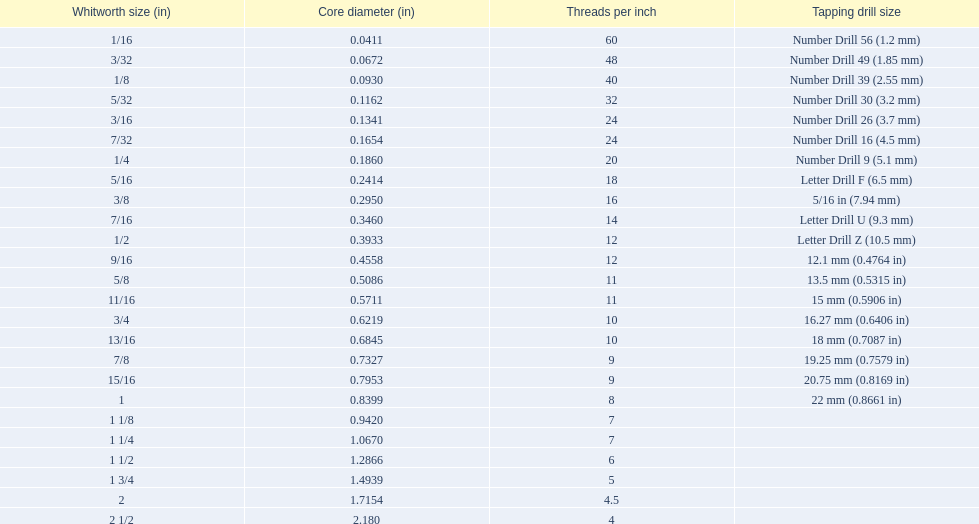What are all of the whitworth sizes in the british standard whitworth? 1/16, 3/32, 1/8, 5/32, 3/16, 7/32, 1/4, 5/16, 3/8, 7/16, 1/2, 9/16, 5/8, 11/16, 3/4, 13/16, 7/8, 15/16, 1, 1 1/8, 1 1/4, 1 1/2, 1 3/4, 2, 2 1/2. Which of these sizes uses a tapping drill size of 26? 3/16. 